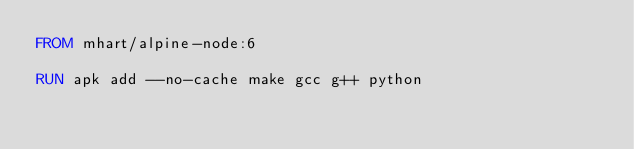<code> <loc_0><loc_0><loc_500><loc_500><_Dockerfile_>FROM mhart/alpine-node:6

RUN apk add --no-cache make gcc g++ python</code> 